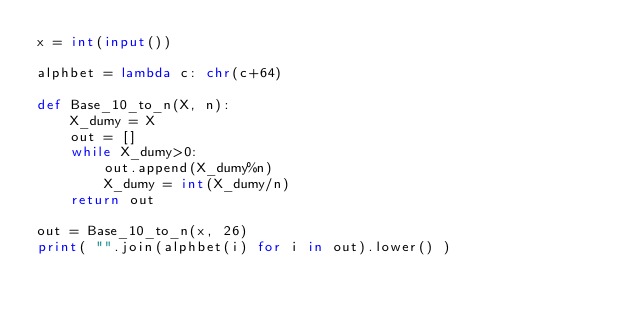Convert code to text. <code><loc_0><loc_0><loc_500><loc_500><_Python_>x = int(input())

alphbet = lambda c: chr(c+64)

def Base_10_to_n(X, n):
    X_dumy = X
    out = []
    while X_dumy>0:
        out.append(X_dumy%n)
        X_dumy = int(X_dumy/n)
    return out

out = Base_10_to_n(x, 26)
print( "".join(alphbet(i) for i in out).lower() )</code> 